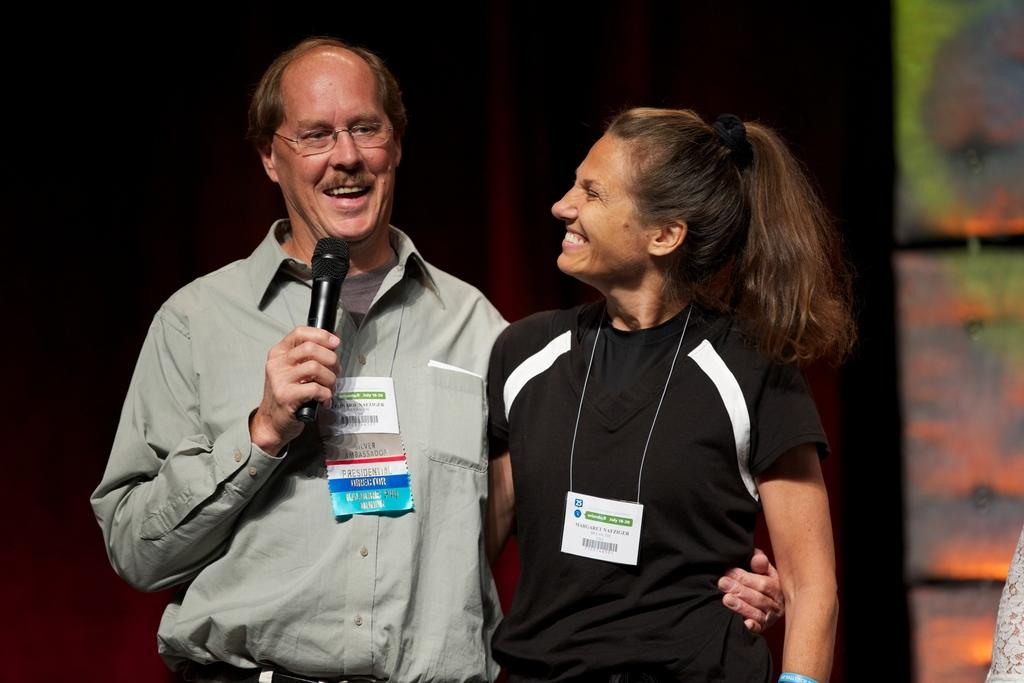How many people are in the image? There are two people in the image, a man and a woman. What are the positions of the man and woman in the image? The man and woman are both standing in the image. What is the man holding in his hands? The man is holding a mic in his hands. What type of education is being taught in the prison scene depicted in the image? There is no prison or education scene present in the image; it features a man and a woman standing with the man holding a mic. 